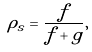Convert formula to latex. <formula><loc_0><loc_0><loc_500><loc_500>\rho _ { s } = \frac { f } { f + g } ,</formula> 